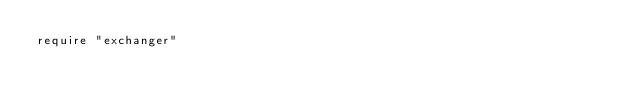<code> <loc_0><loc_0><loc_500><loc_500><_Ruby_>require "exchanger"
</code> 